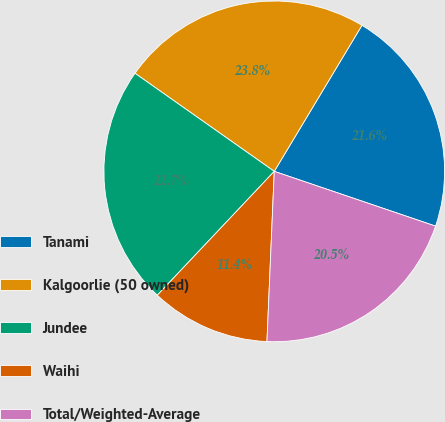Convert chart to OTSL. <chart><loc_0><loc_0><loc_500><loc_500><pie_chart><fcel>Tanami<fcel>Kalgoorlie (50 owned)<fcel>Jundee<fcel>Waihi<fcel>Total/Weighted-Average<nl><fcel>21.6%<fcel>23.84%<fcel>22.72%<fcel>11.36%<fcel>20.47%<nl></chart> 